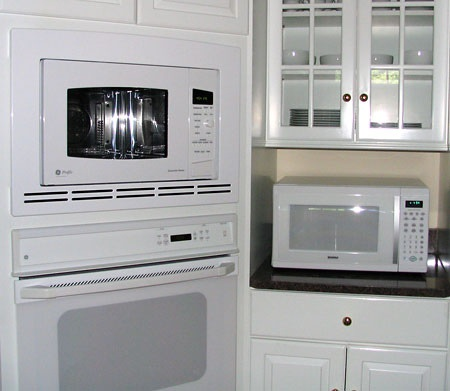Describe the objects in this image and their specific colors. I can see oven in lightgray, darkgray, and gray tones, microwave in lightgray, darkgray, black, and gray tones, microwave in lightgray, darkgray, and gray tones, bowl in lightgray, darkgray, gray, and lavender tones, and bowl in lightgray, gray, and lavender tones in this image. 